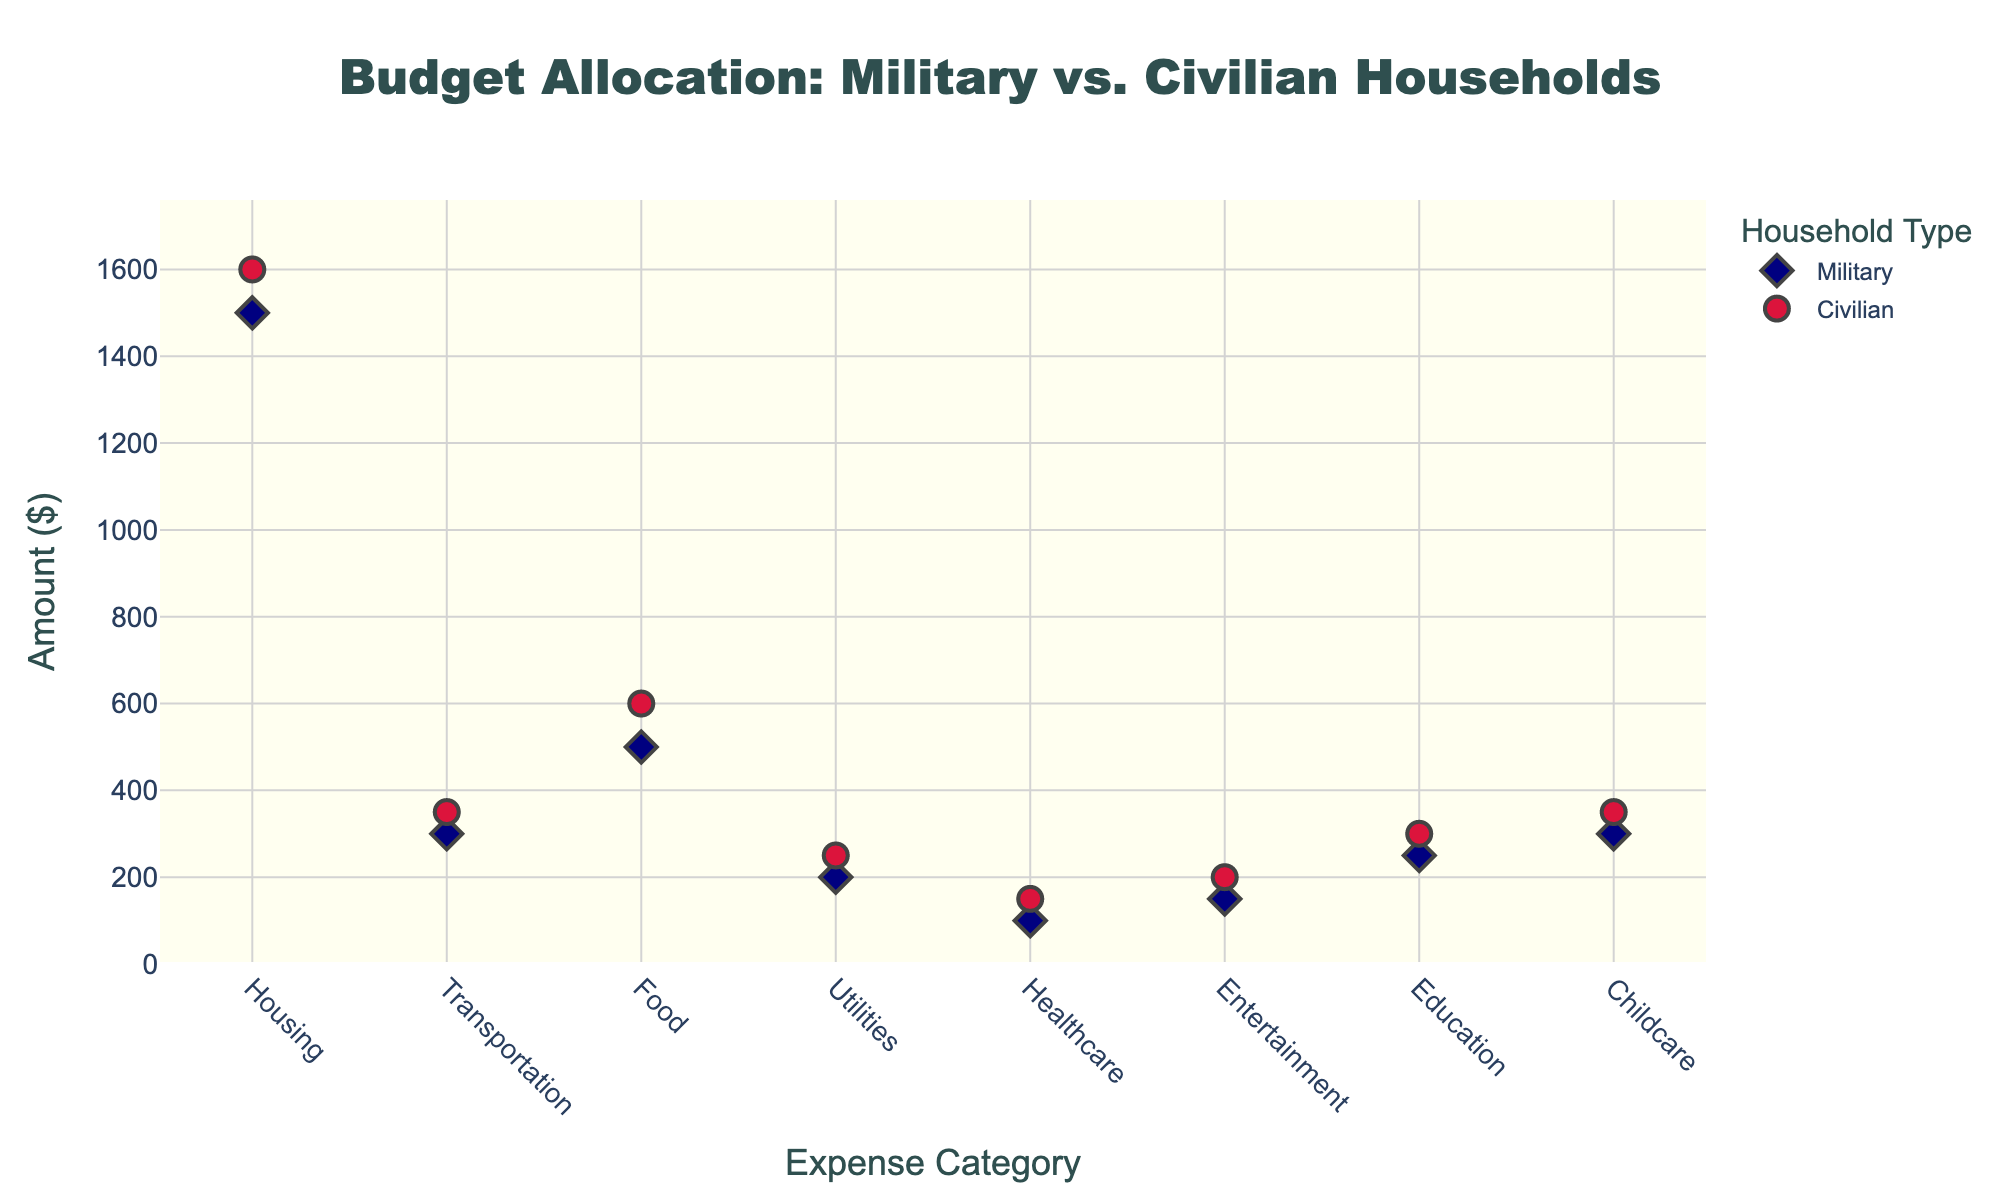what is the title of the figure? The title of the figure is mentioned at the top and reads "Budget Allocation: Military vs. Civilian Households"
Answer: Budget Allocation: Military vs. Civilian Households What is the y-axis label? The y-axis label is shown vertically along the y-axis and it says "Amount ($)"
Answer: Amount ($) How many expense categories are compared in the plot? By counting the distinct markers on the x-axis, we can see there are 8 different expense categories compared in the plot
Answer: 8 Which household type spends more on Housing? Military households have a marker at $1500, while Civilian households have a marker at $1600 on the Housing category
Answer: Civilian What is the difference in Entertainment expenses between Military and Civilian households? Military households spend $150 on entertainment, whereas Civilian households spend $200. Thus, the difference is $200 - $150
Answer: $50 Which category shows the largest expense for Civilian households? By looking at the highest marker on the plot for Civilian households, Housing shows the largest expense at $1600
Answer: Housing What is the combined total amount spent on Food by both household types? Military households spend $500 on food, while Civilian households spend $600. Adding these amounts together gives $500 + $600
Answer: $1100 For which categories do Military and Civilian households spend the same amount? Comparing markers for both types of households, we find that they spend the same amount on Education with markers at $250 and $300
Answer: None (Education is similar but not the same) Which expense category has the smallest expenditure by both household types? For Military households, Healthcare is the smallest at $100. For Civilian households, Healthcare is also the smallest at $150
Answer: Healthcare Which categories do Military households spend less than Civilians? By comparing markers, Military households spend less on Housing, Transportation, Food, Utilities, Healthcare, and Entertainment compared to Civilian households
Answer: Housing, Transportation, Food, Utilities, Healthcare, Entertainment 